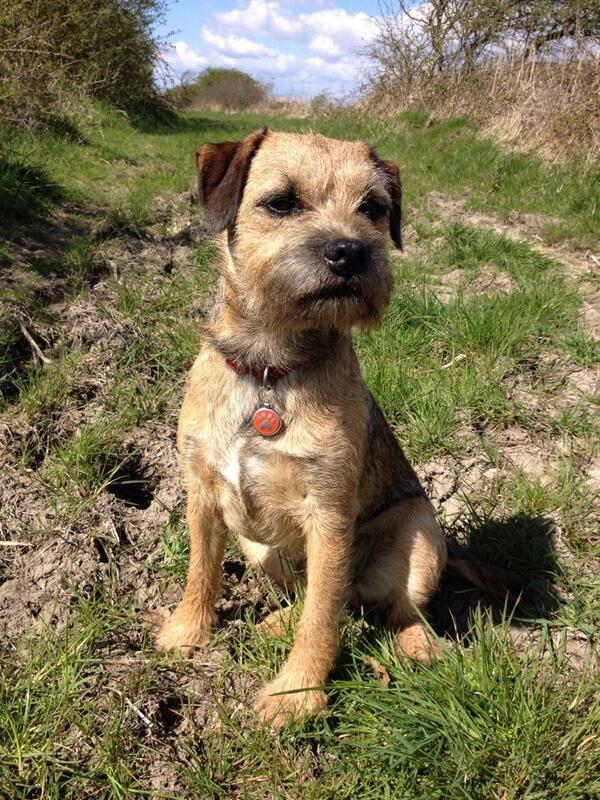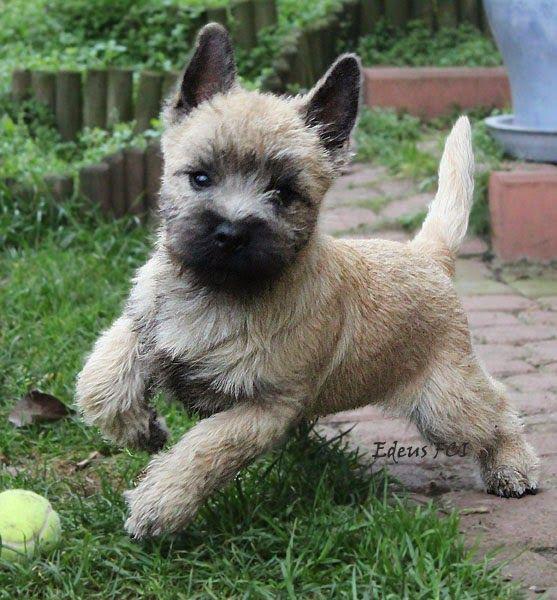The first image is the image on the left, the second image is the image on the right. Assess this claim about the two images: "The left and right image contains the same number of dogs with one running on grass.". Correct or not? Answer yes or no. Yes. The first image is the image on the left, the second image is the image on the right. Assess this claim about the two images: "The left image shows a dog sitting with all paws on the grass.". Correct or not? Answer yes or no. Yes. 